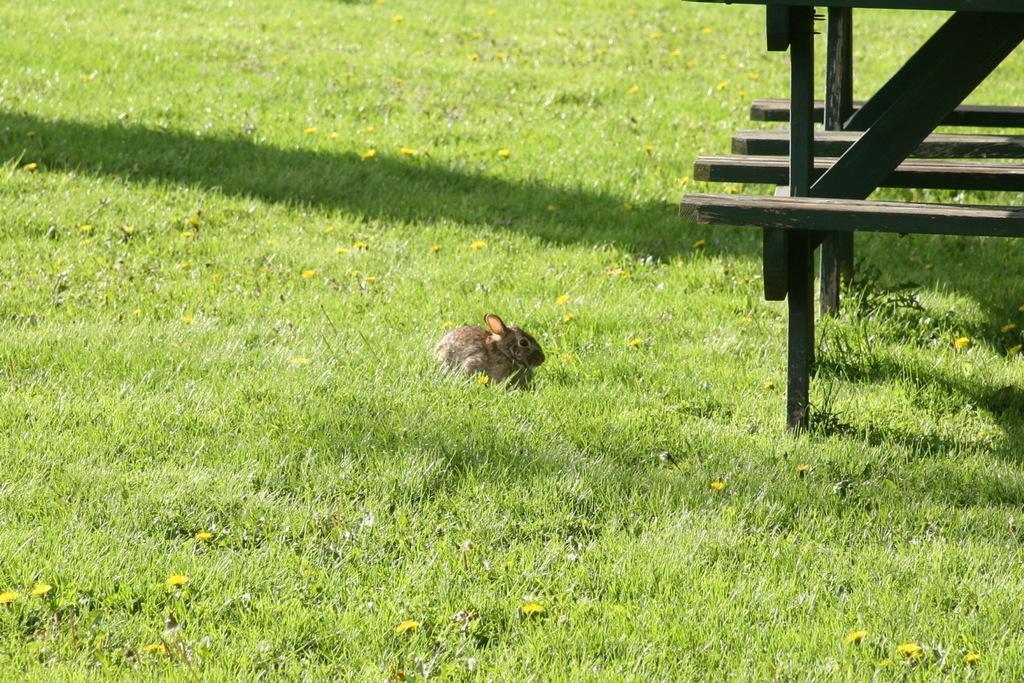Please provide a concise description of this image. In this image, we can see animal and grass, flowers. On right side, we can see wooden rods. 